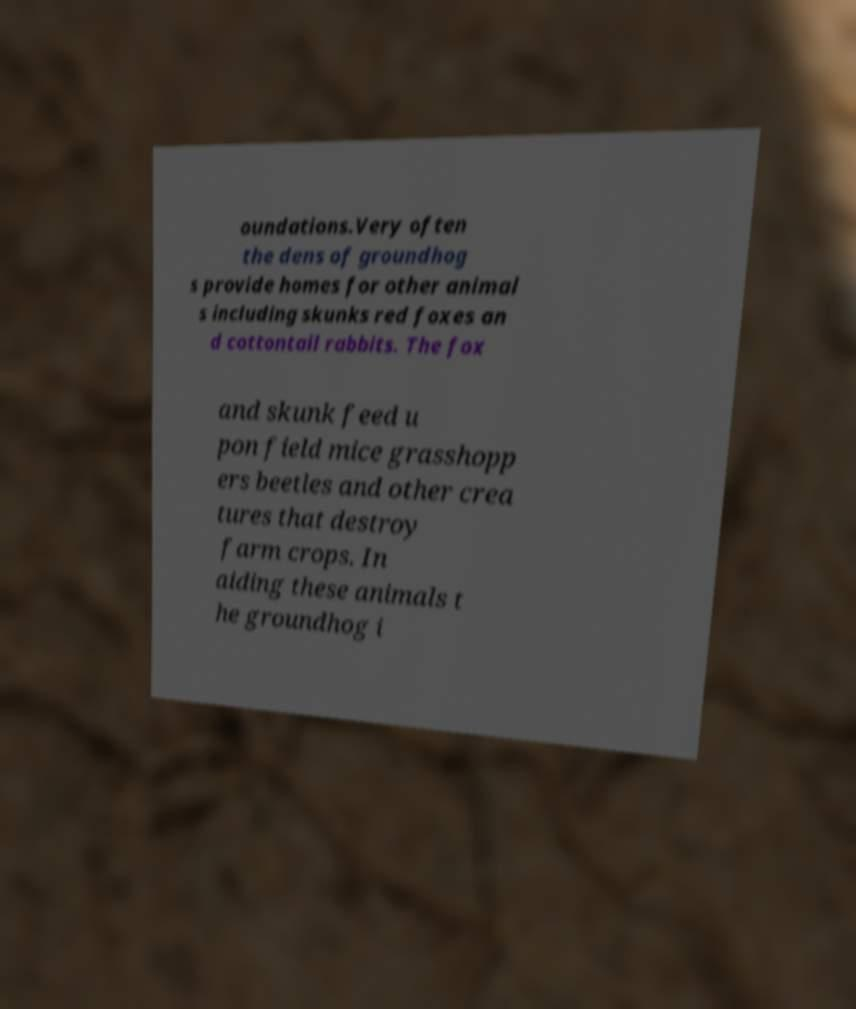Please identify and transcribe the text found in this image. oundations.Very often the dens of groundhog s provide homes for other animal s including skunks red foxes an d cottontail rabbits. The fox and skunk feed u pon field mice grasshopp ers beetles and other crea tures that destroy farm crops. In aiding these animals t he groundhog i 